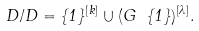<formula> <loc_0><loc_0><loc_500><loc_500>D / D = \{ 1 \} ^ { [ k ] } \cup ( G \ \{ 1 \} ) ^ { [ \lambda ] } .</formula> 